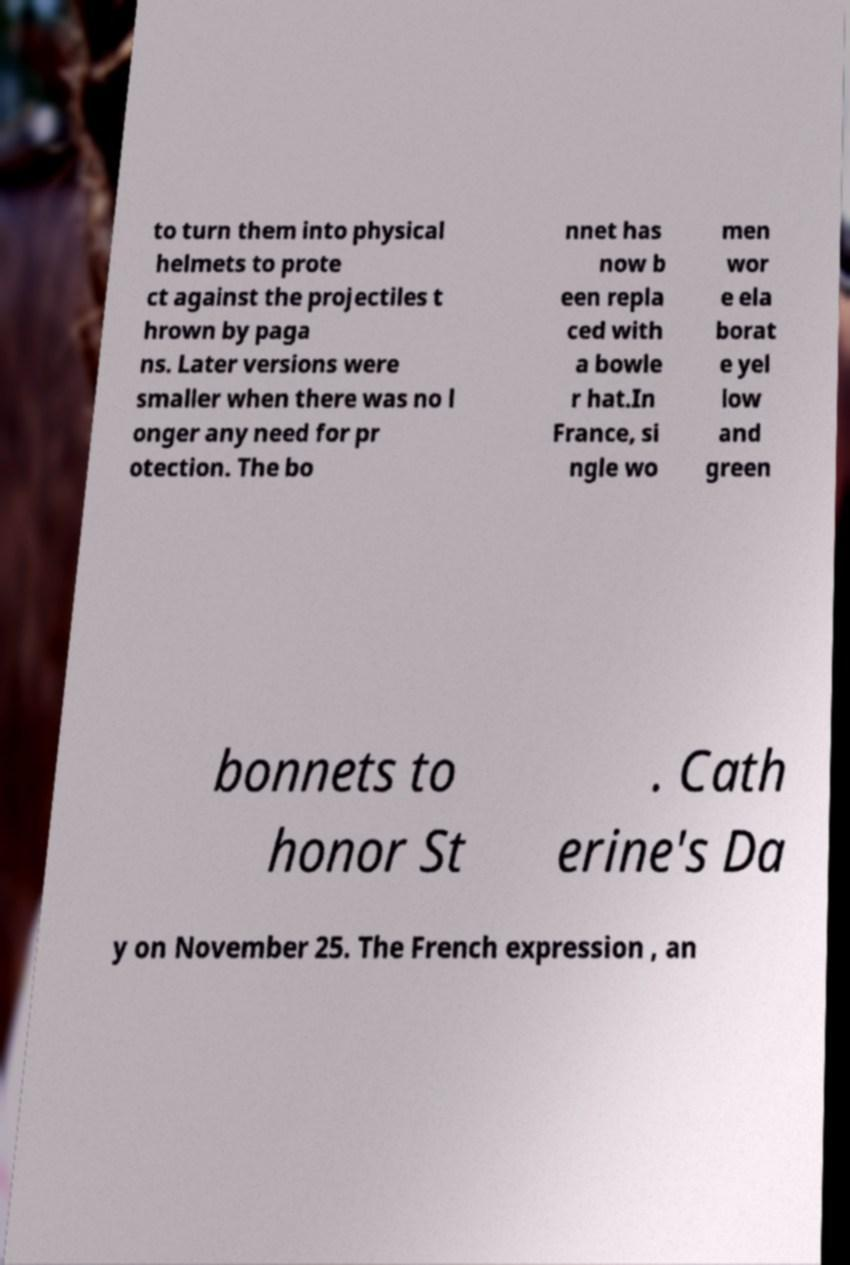Can you read and provide the text displayed in the image?This photo seems to have some interesting text. Can you extract and type it out for me? to turn them into physical helmets to prote ct against the projectiles t hrown by paga ns. Later versions were smaller when there was no l onger any need for pr otection. The bo nnet has now b een repla ced with a bowle r hat.In France, si ngle wo men wor e ela borat e yel low and green bonnets to honor St . Cath erine's Da y on November 25. The French expression , an 